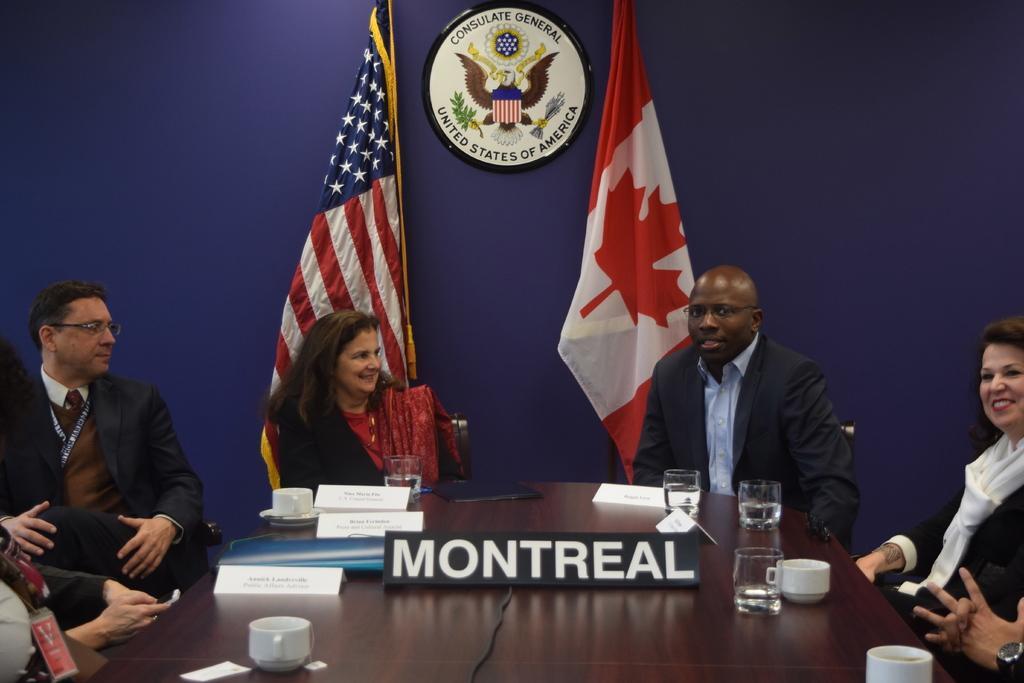Please provide a concise description of this image. There are group of people sitting in chairs and there is a table in front of them and the table consists of cup,glass and there are two flags in the background which are attached to the blue wall. 